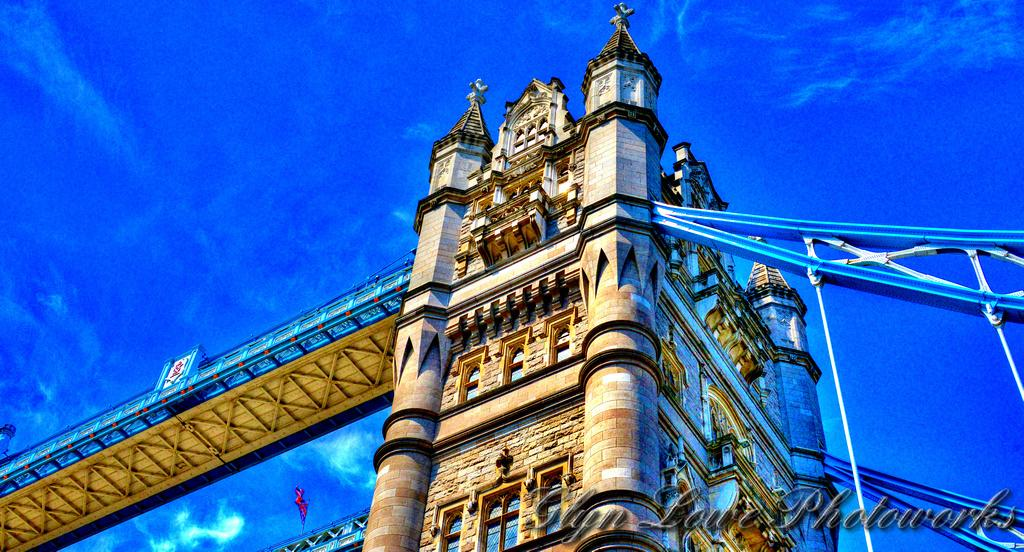What type of structure can be seen in the image? There is a bridge in the image. What other type of structure is present in the image? There is a building in the image. What material is used for the rods visible in the image? The rods in the image are made of metal. What can be seen in the sky in the image? There are clouds visible in the image. Where is the text located in the image? The text is at the right bottom of the image. What type of lettuce is being used as a scarf by the person in the image? There is no person or lettuce present in the image. What activity is the person in the image participating in? There is no person present in the image, so it is impossible to determine what activity they might be participating in. 